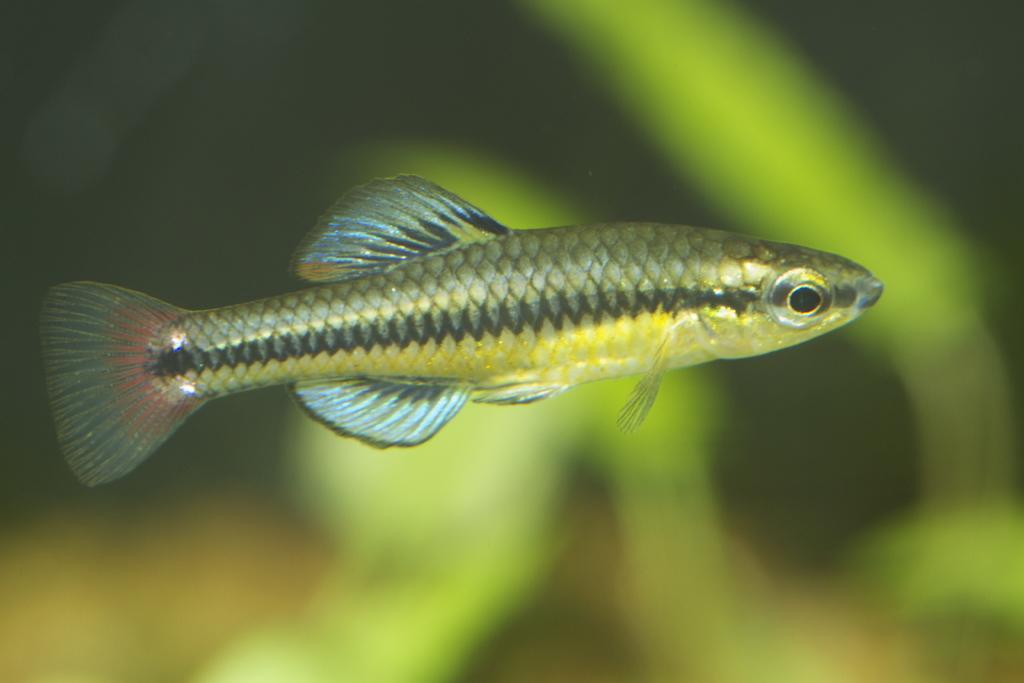What is the main subject of the image? There is a fish in the image. Can you describe the background of the image? The background of the image is blurred. What is the actor's reaction to the disgusting table in the image? There is no actor, disgusting table, or any indication of a reaction in the image; it only features a fish with a blurred background. 